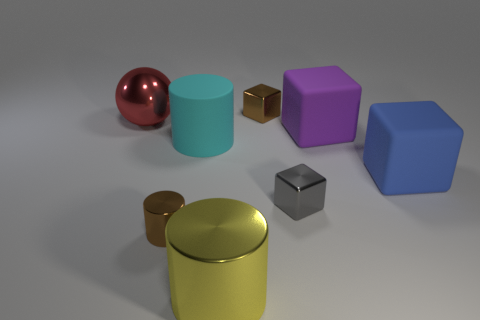What color is the other large block that is made of the same material as the big purple block?
Give a very brief answer. Blue. The object that is the same color as the tiny shiny cylinder is what shape?
Give a very brief answer. Cube. Are there the same number of big blue rubber blocks that are behind the big blue block and small brown metal things that are in front of the brown cylinder?
Provide a short and direct response. Yes. What is the shape of the small metal thing to the left of the tiny brown object that is to the right of the yellow shiny cylinder?
Provide a short and direct response. Cylinder. There is a small gray object that is the same shape as the big blue thing; what is its material?
Provide a short and direct response. Metal. What is the color of the cylinder that is the same size as the cyan thing?
Your answer should be compact. Yellow. Are there the same number of cyan rubber objects that are to the left of the cyan rubber cylinder and large purple blocks?
Make the answer very short. No. There is a small block on the right side of the small shiny thing that is behind the big red shiny sphere; what is its color?
Provide a succinct answer. Gray. What is the size of the brown object that is right of the large yellow metallic cylinder that is in front of the brown metal block?
Provide a succinct answer. Small. There is a metallic thing that is the same color as the tiny metallic cylinder; what size is it?
Ensure brevity in your answer.  Small. 